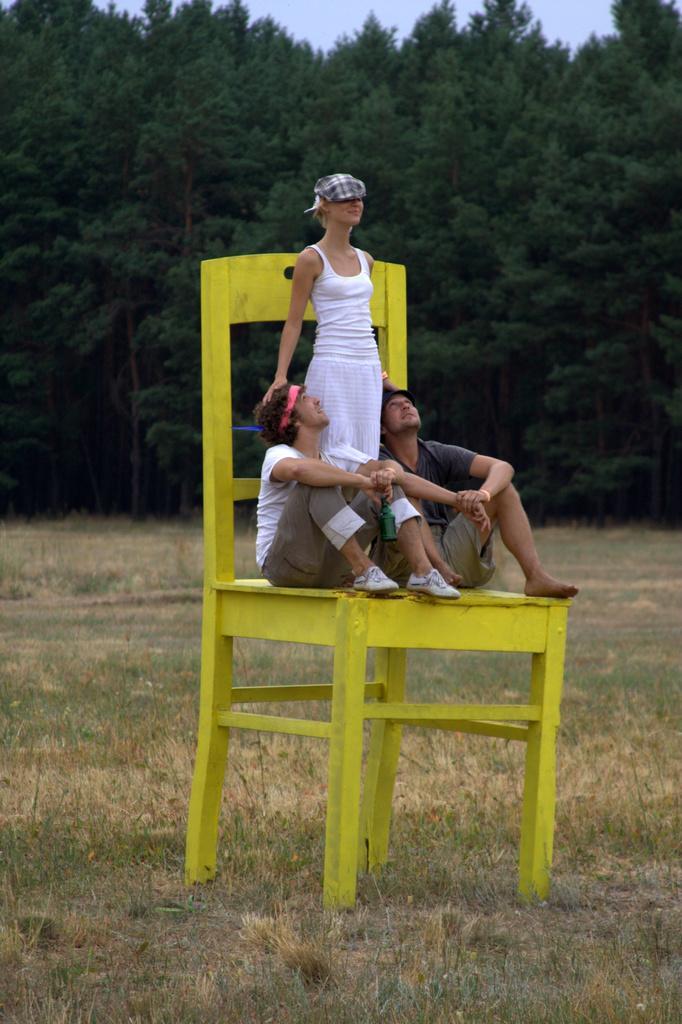In one or two sentences, can you explain what this image depicts? Here we can see a woman and two men on the chair. This is grass. In the background we can see trees and sky. 